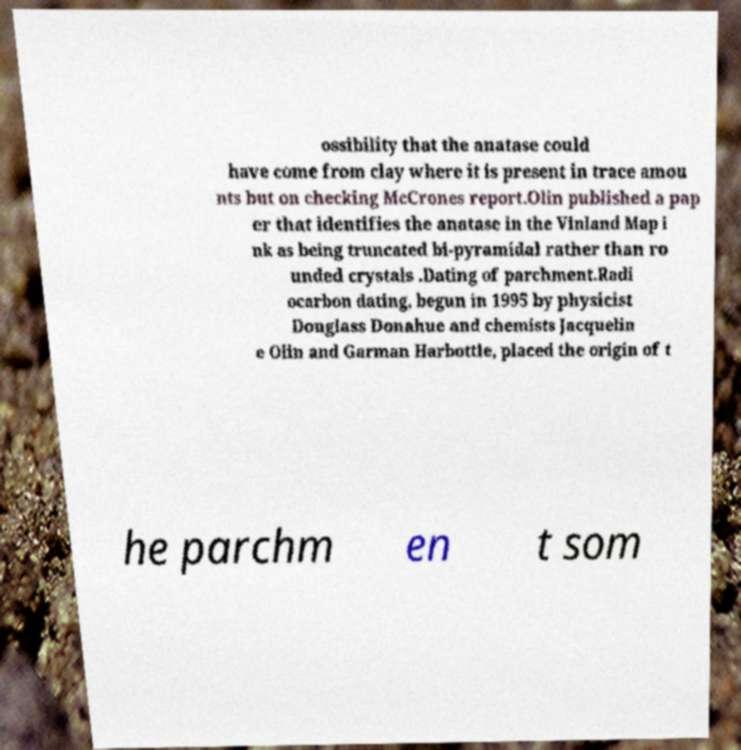For documentation purposes, I need the text within this image transcribed. Could you provide that? ossibility that the anatase could have come from clay where it is present in trace amou nts but on checking McCrones report.Olin published a pap er that identifies the anatase in the Vinland Map i nk as being truncated bi-pyramidal rather than ro unded crystals .Dating of parchment.Radi ocarbon dating, begun in 1995 by physicist Douglass Donahue and chemists Jacquelin e Olin and Garman Harbottle, placed the origin of t he parchm en t som 